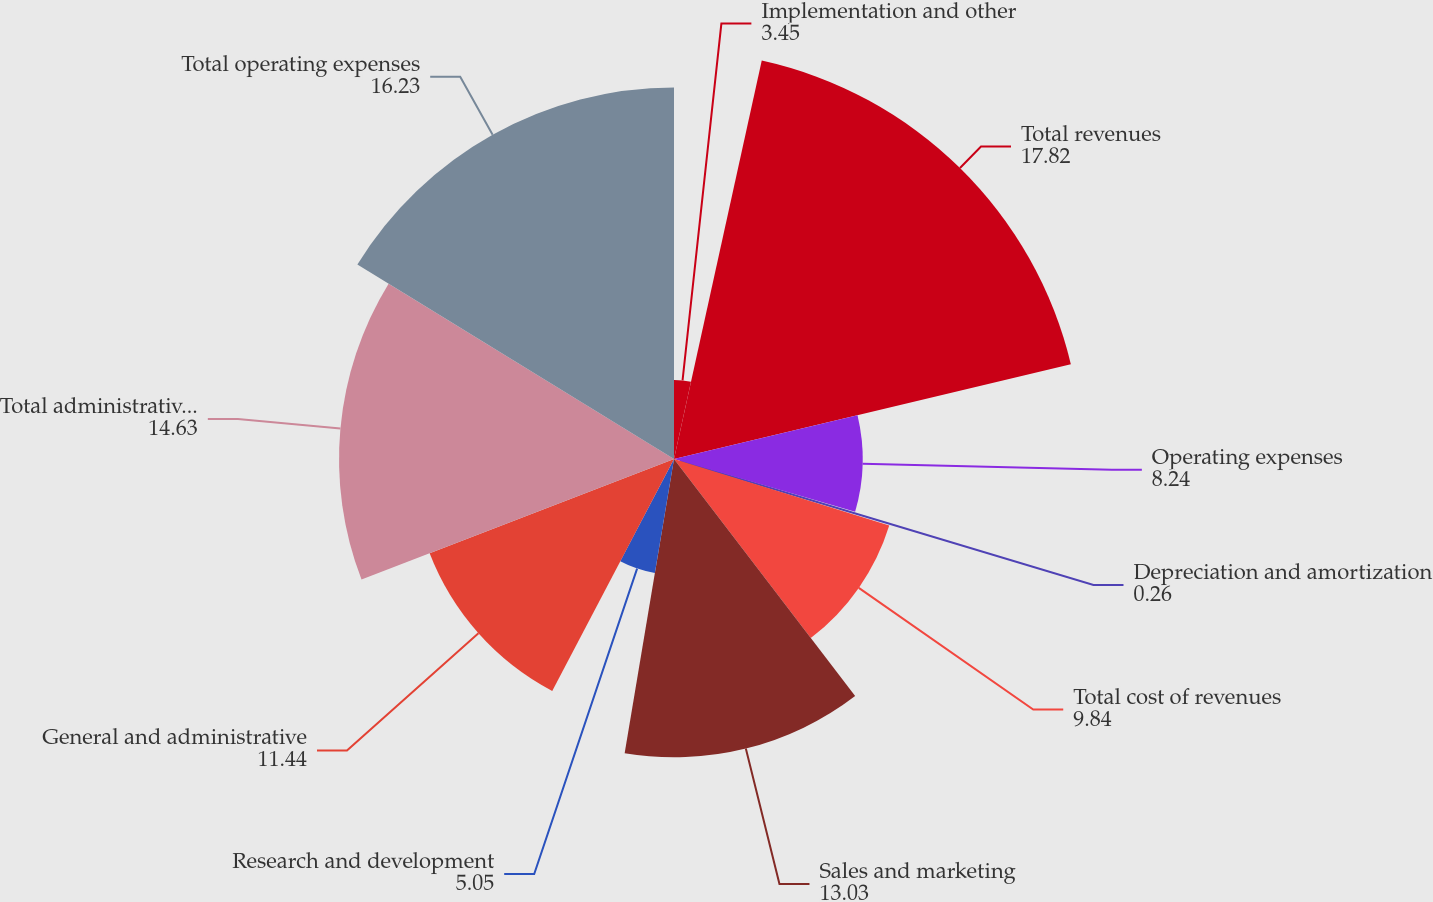Convert chart. <chart><loc_0><loc_0><loc_500><loc_500><pie_chart><fcel>Implementation and other<fcel>Total revenues<fcel>Operating expenses<fcel>Depreciation and amortization<fcel>Total cost of revenues<fcel>Sales and marketing<fcel>Research and development<fcel>General and administrative<fcel>Total administrative expenses<fcel>Total operating expenses<nl><fcel>3.45%<fcel>17.82%<fcel>8.24%<fcel>0.26%<fcel>9.84%<fcel>13.03%<fcel>5.05%<fcel>11.44%<fcel>14.63%<fcel>16.23%<nl></chart> 